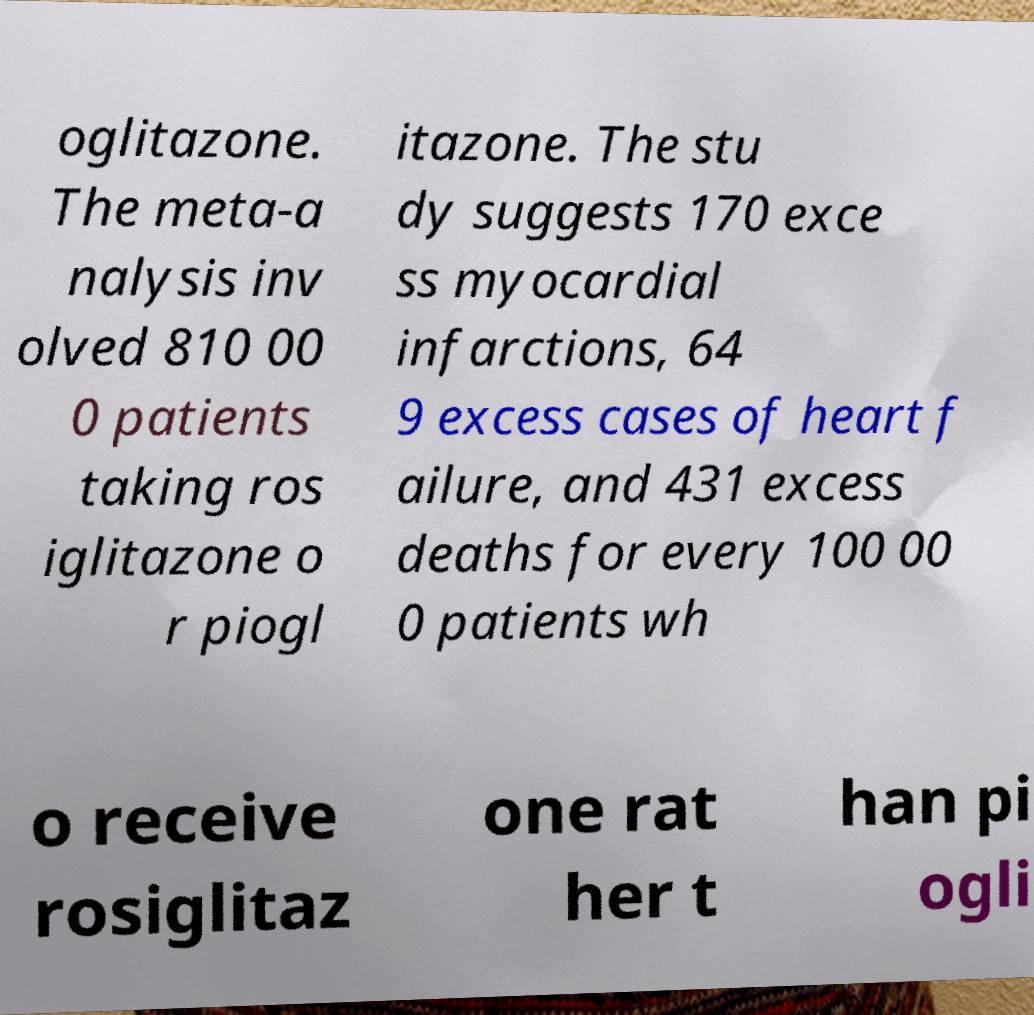Please identify and transcribe the text found in this image. oglitazone. The meta-a nalysis inv olved 810 00 0 patients taking ros iglitazone o r piogl itazone. The stu dy suggests 170 exce ss myocardial infarctions, 64 9 excess cases of heart f ailure, and 431 excess deaths for every 100 00 0 patients wh o receive rosiglitaz one rat her t han pi ogli 